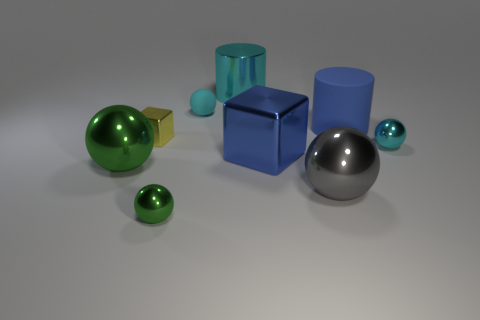What is the size of the yellow object?
Your answer should be compact. Small. What is the color of the large thing behind the tiny cyan rubber ball that is behind the yellow metal object?
Offer a terse response. Cyan. How many metal objects are to the right of the big green object and behind the big gray metal object?
Keep it short and to the point. 4. Are there more gray objects than red metallic spheres?
Provide a short and direct response. Yes. What is the material of the large green sphere?
Your response must be concise. Metal. What number of small cyan rubber things are on the left side of the cyan object that is right of the big blue block?
Provide a short and direct response. 1. There is a large block; does it have the same color as the large matte cylinder that is right of the large cyan thing?
Your answer should be very brief. Yes. What is the color of the shiny cube that is the same size as the cyan metallic ball?
Offer a terse response. Yellow. Are there any other objects that have the same shape as the tiny cyan matte object?
Provide a short and direct response. Yes. Are there fewer small yellow objects than blue shiny spheres?
Give a very brief answer. No. 